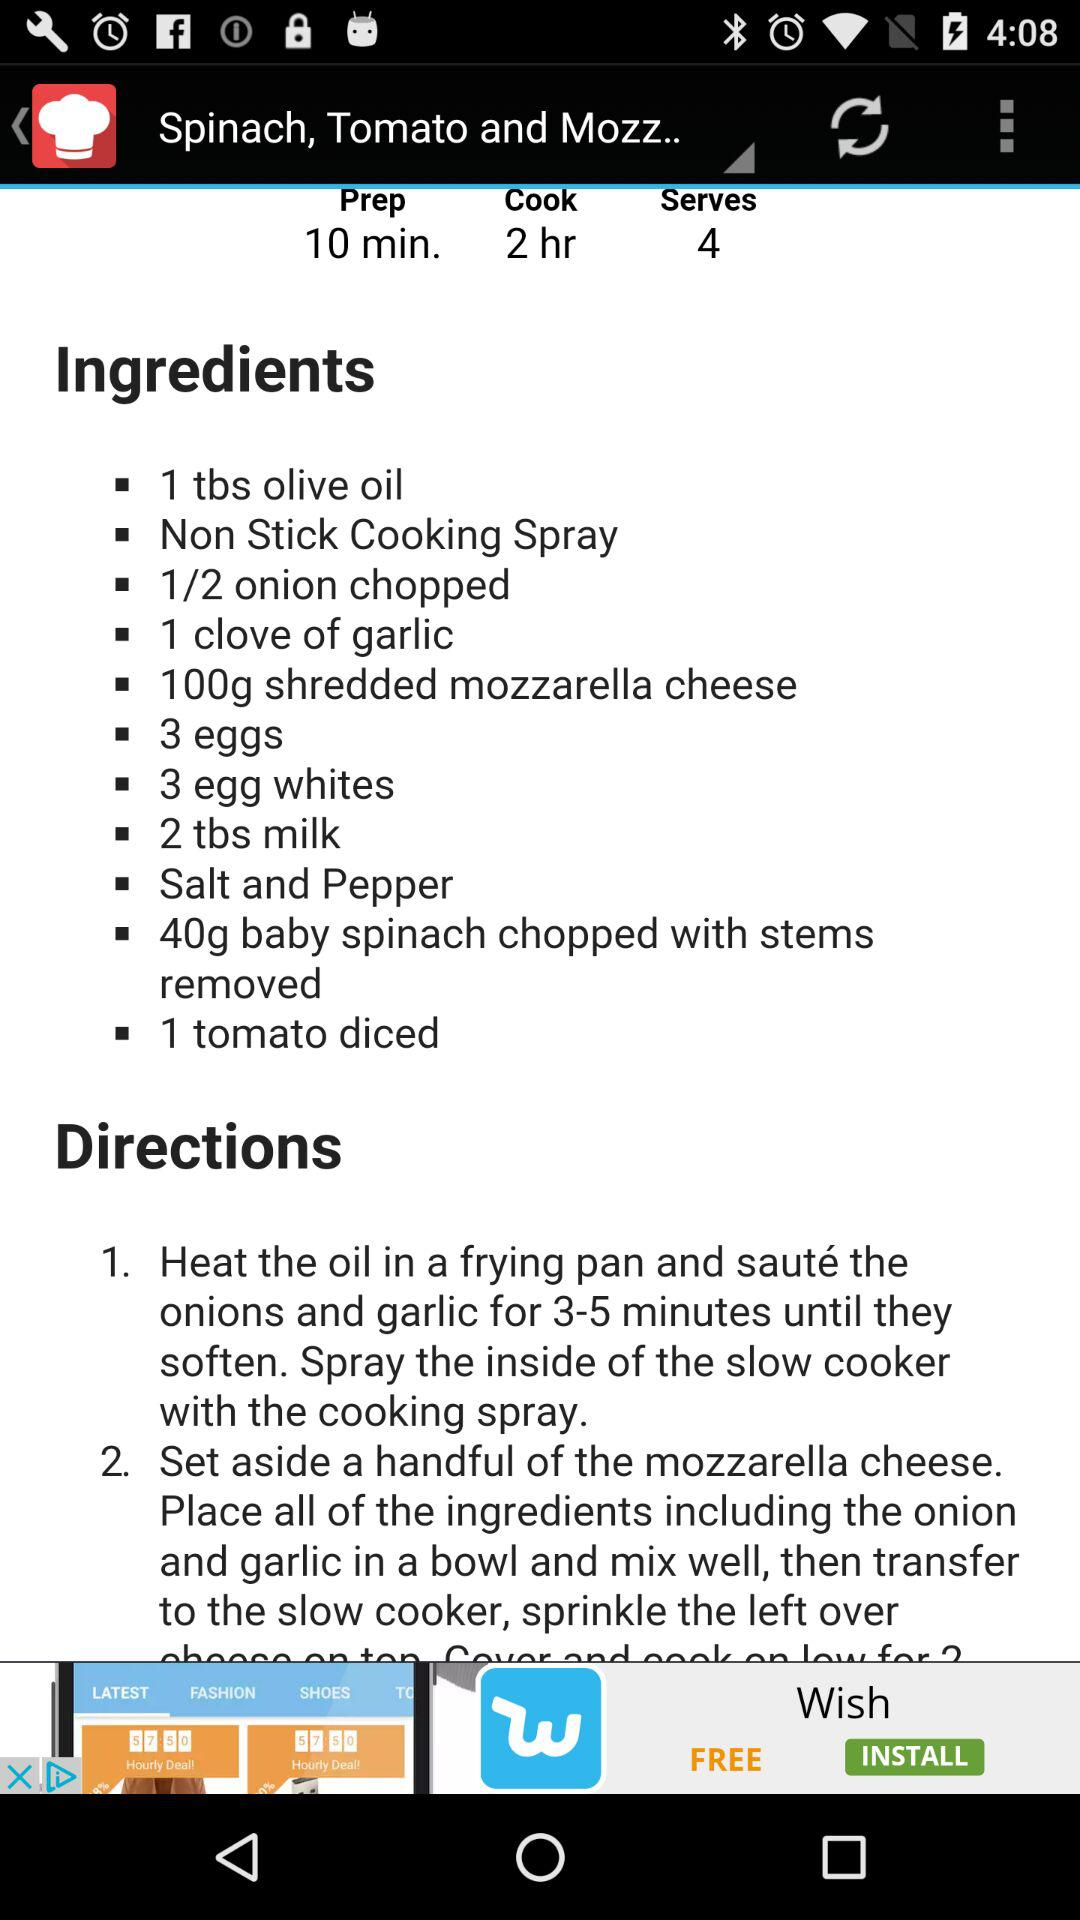How many servings are there? There are 4 servings. 